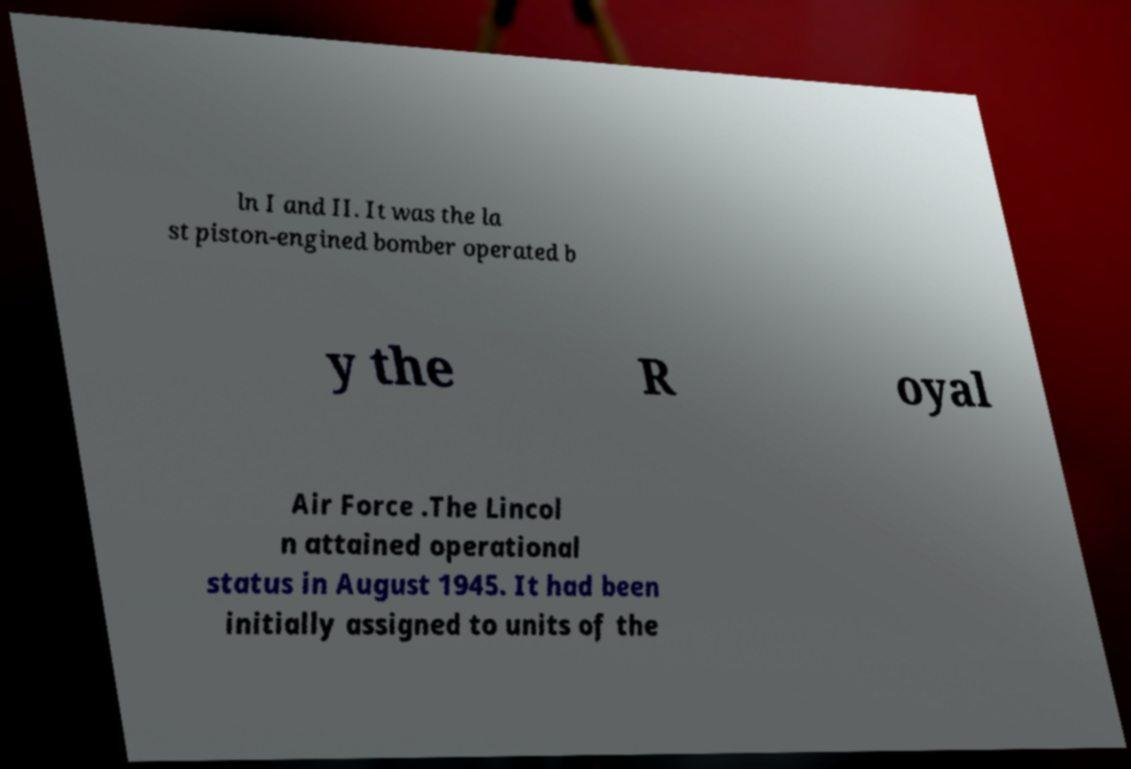Could you assist in decoding the text presented in this image and type it out clearly? ln I and II. It was the la st piston-engined bomber operated b y the R oyal Air Force .The Lincol n attained operational status in August 1945. It had been initially assigned to units of the 